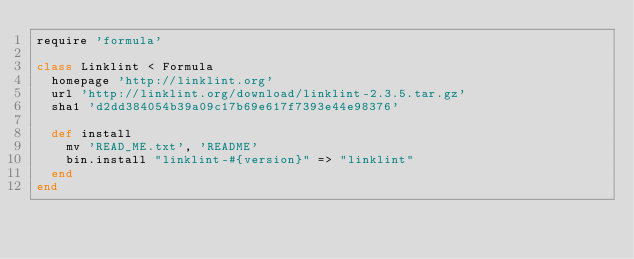Convert code to text. <code><loc_0><loc_0><loc_500><loc_500><_Ruby_>require 'formula'

class Linklint < Formula
  homepage 'http://linklint.org'
  url 'http://linklint.org/download/linklint-2.3.5.tar.gz'
  sha1 'd2dd384054b39a09c17b69e617f7393e44e98376'

  def install
    mv 'READ_ME.txt', 'README'
    bin.install "linklint-#{version}" => "linklint"
  end
end
</code> 